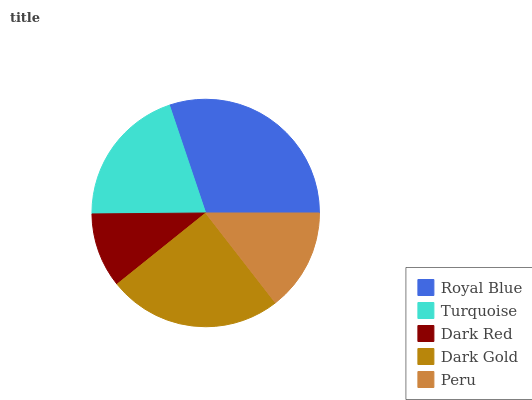Is Dark Red the minimum?
Answer yes or no. Yes. Is Royal Blue the maximum?
Answer yes or no. Yes. Is Turquoise the minimum?
Answer yes or no. No. Is Turquoise the maximum?
Answer yes or no. No. Is Royal Blue greater than Turquoise?
Answer yes or no. Yes. Is Turquoise less than Royal Blue?
Answer yes or no. Yes. Is Turquoise greater than Royal Blue?
Answer yes or no. No. Is Royal Blue less than Turquoise?
Answer yes or no. No. Is Turquoise the high median?
Answer yes or no. Yes. Is Turquoise the low median?
Answer yes or no. Yes. Is Dark Red the high median?
Answer yes or no. No. Is Royal Blue the low median?
Answer yes or no. No. 